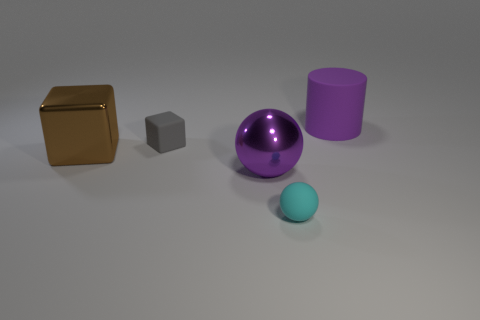Which object in the image seems closest to the viewpoint? The closest object to the viewpoint appears to be the small blue sphere. Is there any object that appears reflective or shiny? Yes, the purple sphere has a shiny surface that reflects the environment. 